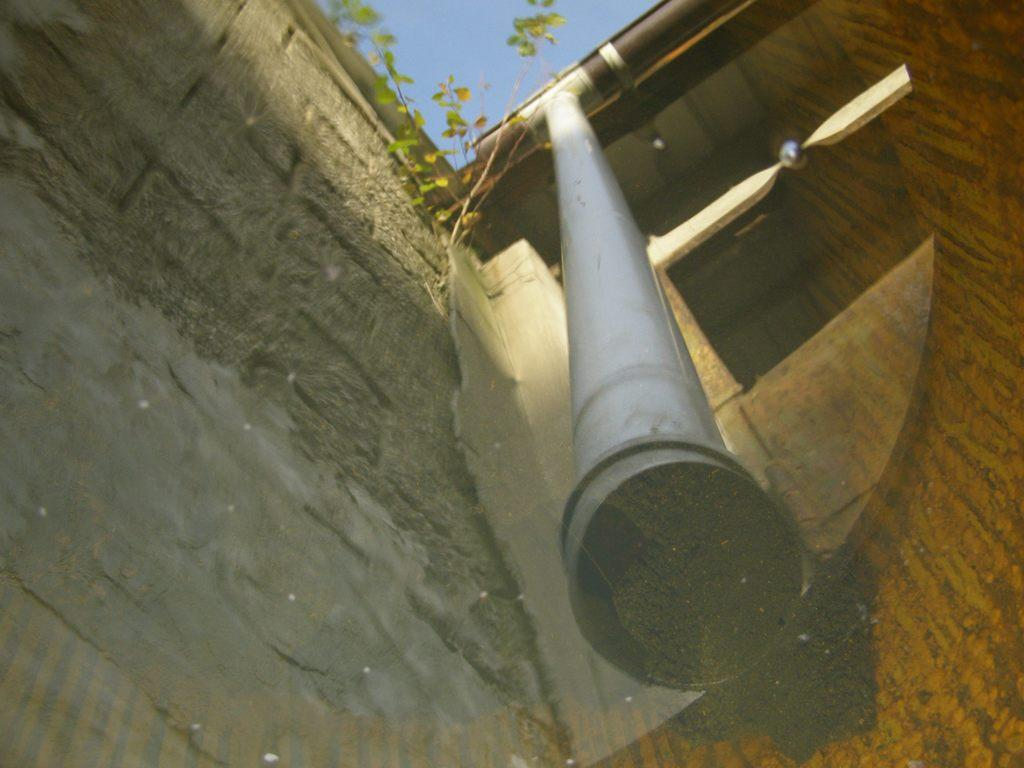What is located in the foreground of the image? There is a mirror in the foreground of the image. What can be seen through the mirror? A house, a pipe, plants, and the sky are visible through the mirror. Can you describe the reflection in the mirror? The reflection in the mirror shows a house, a pipe, plants, and the sky. What type of advertisement is displayed on the actor's shirt in the image? There is no actor or advertisement present in the image; it features a mirror reflecting a house, a pipe, plants, and the sky. 